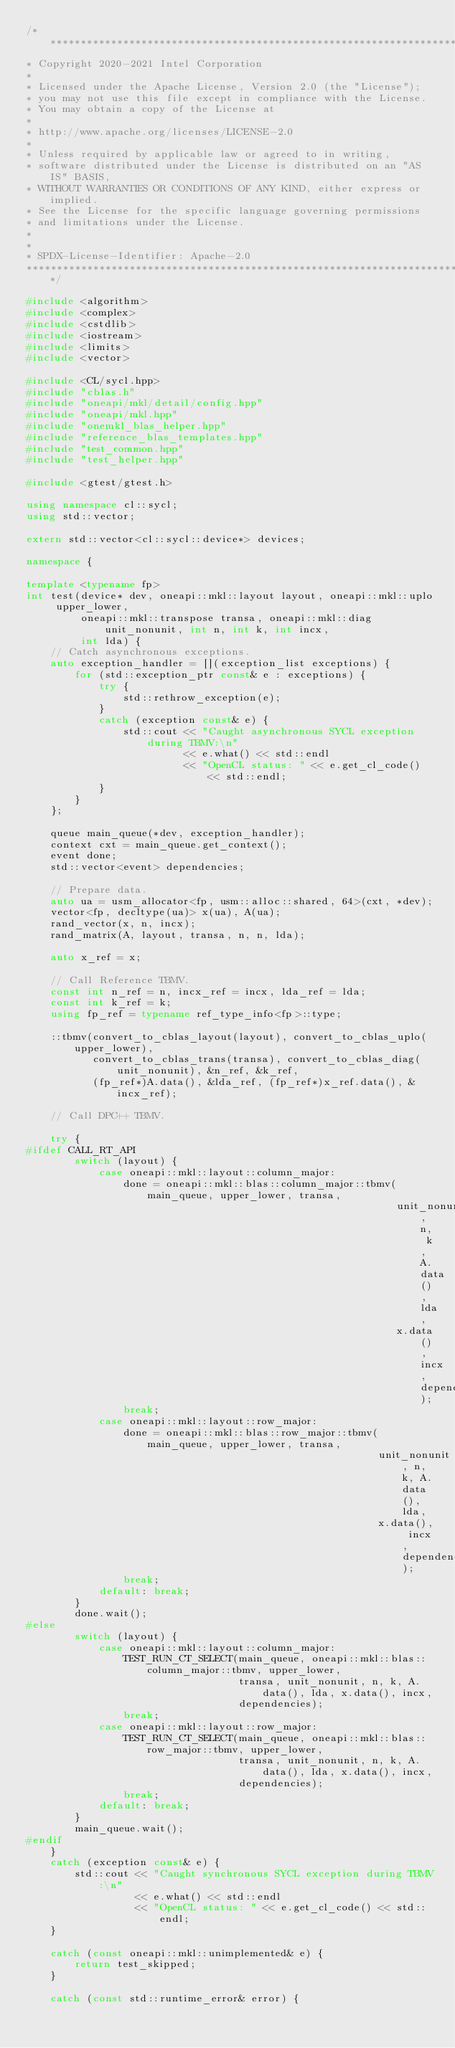Convert code to text. <code><loc_0><loc_0><loc_500><loc_500><_C++_>/*******************************************************************************
* Copyright 2020-2021 Intel Corporation
*
* Licensed under the Apache License, Version 2.0 (the "License");
* you may not use this file except in compliance with the License.
* You may obtain a copy of the License at
*
* http://www.apache.org/licenses/LICENSE-2.0
*
* Unless required by applicable law or agreed to in writing,
* software distributed under the License is distributed on an "AS IS" BASIS,
* WITHOUT WARRANTIES OR CONDITIONS OF ANY KIND, either express or implied.
* See the License for the specific language governing permissions
* and limitations under the License.
*
*
* SPDX-License-Identifier: Apache-2.0
*******************************************************************************/

#include <algorithm>
#include <complex>
#include <cstdlib>
#include <iostream>
#include <limits>
#include <vector>

#include <CL/sycl.hpp>
#include "cblas.h"
#include "oneapi/mkl/detail/config.hpp"
#include "oneapi/mkl.hpp"
#include "onemkl_blas_helper.hpp"
#include "reference_blas_templates.hpp"
#include "test_common.hpp"
#include "test_helper.hpp"

#include <gtest/gtest.h>

using namespace cl::sycl;
using std::vector;

extern std::vector<cl::sycl::device*> devices;

namespace {

template <typename fp>
int test(device* dev, oneapi::mkl::layout layout, oneapi::mkl::uplo upper_lower,
         oneapi::mkl::transpose transa, oneapi::mkl::diag unit_nonunit, int n, int k, int incx,
         int lda) {
    // Catch asynchronous exceptions.
    auto exception_handler = [](exception_list exceptions) {
        for (std::exception_ptr const& e : exceptions) {
            try {
                std::rethrow_exception(e);
            }
            catch (exception const& e) {
                std::cout << "Caught asynchronous SYCL exception during TBMV:\n"
                          << e.what() << std::endl
                          << "OpenCL status: " << e.get_cl_code() << std::endl;
            }
        }
    };

    queue main_queue(*dev, exception_handler);
    context cxt = main_queue.get_context();
    event done;
    std::vector<event> dependencies;

    // Prepare data.
    auto ua = usm_allocator<fp, usm::alloc::shared, 64>(cxt, *dev);
    vector<fp, decltype(ua)> x(ua), A(ua);
    rand_vector(x, n, incx);
    rand_matrix(A, layout, transa, n, n, lda);

    auto x_ref = x;

    // Call Reference TBMV.
    const int n_ref = n, incx_ref = incx, lda_ref = lda;
    const int k_ref = k;
    using fp_ref = typename ref_type_info<fp>::type;

    ::tbmv(convert_to_cblas_layout(layout), convert_to_cblas_uplo(upper_lower),
           convert_to_cblas_trans(transa), convert_to_cblas_diag(unit_nonunit), &n_ref, &k_ref,
           (fp_ref*)A.data(), &lda_ref, (fp_ref*)x_ref.data(), &incx_ref);

    // Call DPC++ TBMV.

    try {
#ifdef CALL_RT_API
        switch (layout) {
            case oneapi::mkl::layout::column_major:
                done = oneapi::mkl::blas::column_major::tbmv(main_queue, upper_lower, transa,
                                                             unit_nonunit, n, k, A.data(), lda,
                                                             x.data(), incx, dependencies);
                break;
            case oneapi::mkl::layout::row_major:
                done = oneapi::mkl::blas::row_major::tbmv(main_queue, upper_lower, transa,
                                                          unit_nonunit, n, k, A.data(), lda,
                                                          x.data(), incx, dependencies);
                break;
            default: break;
        }
        done.wait();
#else
        switch (layout) {
            case oneapi::mkl::layout::column_major:
                TEST_RUN_CT_SELECT(main_queue, oneapi::mkl::blas::column_major::tbmv, upper_lower,
                                   transa, unit_nonunit, n, k, A.data(), lda, x.data(), incx,
                                   dependencies);
                break;
            case oneapi::mkl::layout::row_major:
                TEST_RUN_CT_SELECT(main_queue, oneapi::mkl::blas::row_major::tbmv, upper_lower,
                                   transa, unit_nonunit, n, k, A.data(), lda, x.data(), incx,
                                   dependencies);
                break;
            default: break;
        }
        main_queue.wait();
#endif
    }
    catch (exception const& e) {
        std::cout << "Caught synchronous SYCL exception during TBMV:\n"
                  << e.what() << std::endl
                  << "OpenCL status: " << e.get_cl_code() << std::endl;
    }

    catch (const oneapi::mkl::unimplemented& e) {
        return test_skipped;
    }

    catch (const std::runtime_error& error) {</code> 